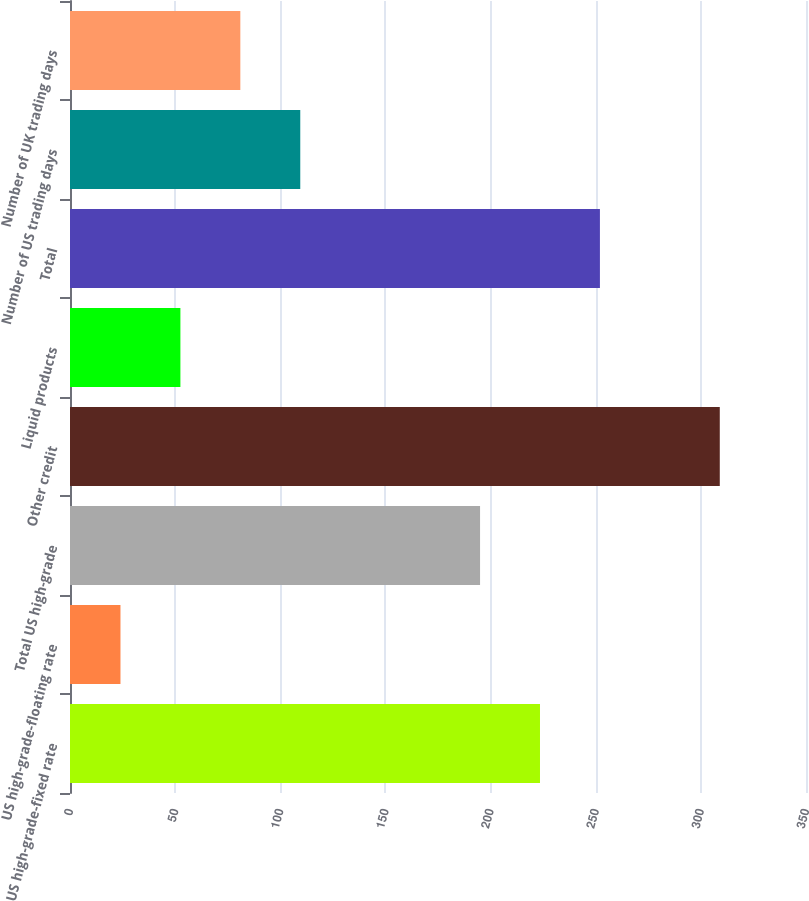<chart> <loc_0><loc_0><loc_500><loc_500><bar_chart><fcel>US high-grade-fixed rate<fcel>US high-grade-floating rate<fcel>Total US high-grade<fcel>Other credit<fcel>Liquid products<fcel>Total<fcel>Number of US trading days<fcel>Number of UK trading days<nl><fcel>223.5<fcel>24<fcel>195<fcel>309<fcel>52.5<fcel>252<fcel>109.5<fcel>81<nl></chart> 